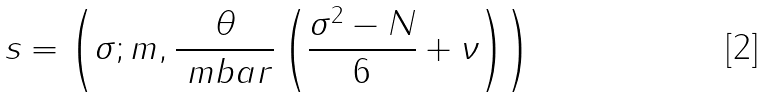Convert formula to latex. <formula><loc_0><loc_0><loc_500><loc_500>s = \left ( \sigma ; m , \frac { \theta } { \ m b a r } \left ( \frac { \sigma ^ { 2 } - N } { 6 } + \nu \right ) \right )</formula> 